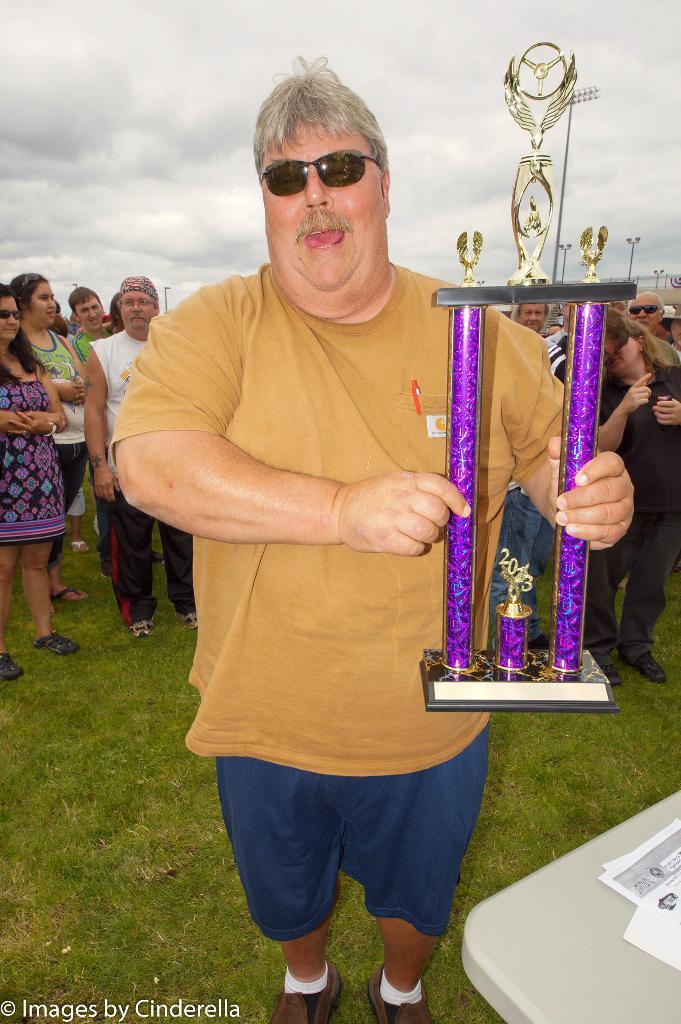In one or two sentences, can you explain what this image depicts? In this image we can see few people standing in the ground, a person is holding a shield, in front of the person there is a table and papers on the table and sky with clouds in the background. 